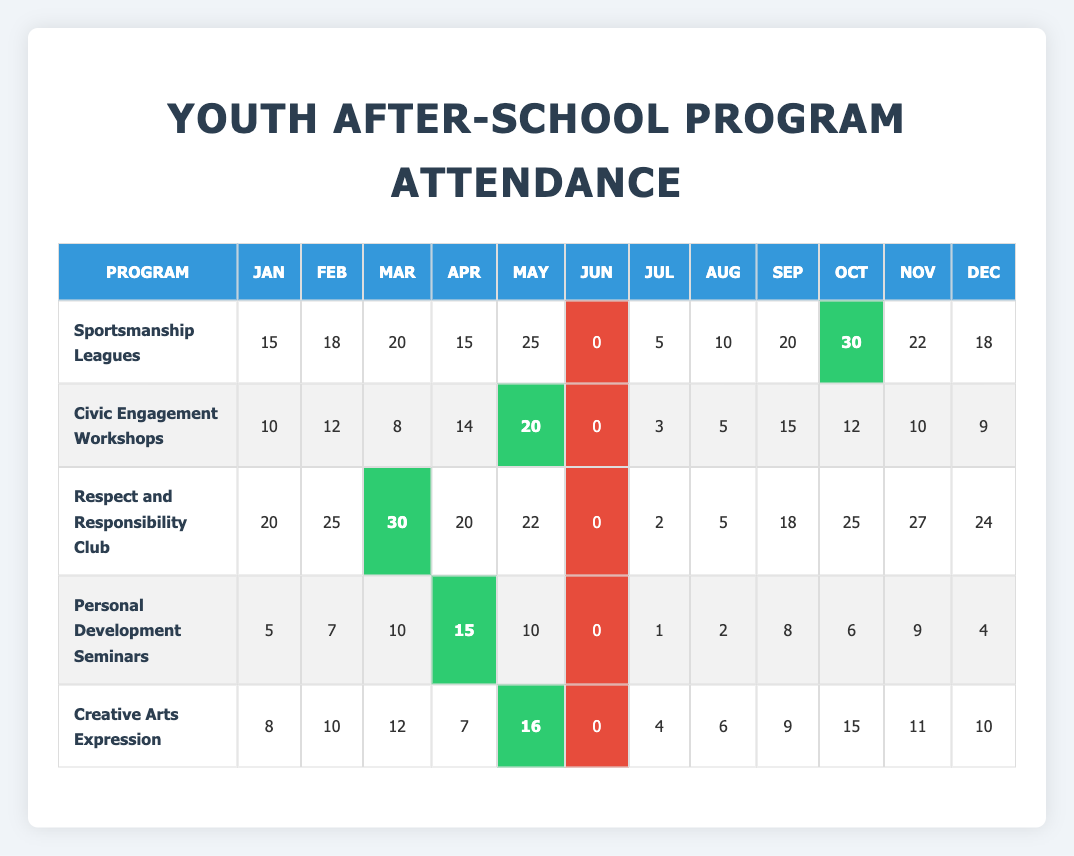What was the attendance in August for the "Sportsmanship Leagues"? The table shows that the "Sportsmanship Leagues" had 10 participants in August.
Answer: 10 Which program had the highest attendance in March? In March, "Respect and Responsibility Club" had 30 participants, which is more than any other program.
Answer: Respect and Responsibility Club What is the total attendance for "Creative Arts Expression" from January to December? Adding together the monthly attendance: 8 + 10 + 12 + 7 + 16 + 0 + 4 + 6 + 9 + 15 + 11 + 10 gives a total of 88 participants.
Answer: 88 Was there a month in which "Personal Development Seminars" had zero attendees? Yes, the data shows that "Personal Development Seminars" had zero attendees in June.
Answer: Yes What is the average attendance for the "Civic Engagement Workshops"? Adding the monthly attendance (10 + 12 + 8 + 14 + 20 + 0 + 3 + 5 + 15 + 12 + 10 + 9 = 108) gives a total of 108; dividing by 12 months gives an average of 9.
Answer: 9 What was the month with the lowest attendance in "Respect and Responsibility Club"? The lowest attendance was in June, with zero participants.
Answer: June Which program had a peak attendance of 30 in which month? The "Sportsmanship Leagues" peaked at 30 participants in October.
Answer: October What can you say about the trend of attendance for "Civic Engagement Workshops" over the year? Looking at the monthly data, attendance fluctuates, with a peak in May (20) followed by declines in June (0) and some growth again towards the end of the year.
Answer: Fluctuating trend Which program showed a consistent increase in attendance month-over-month during the second half of the year? The "Respect and Responsibility Club" showed a consistent increase in attendance month-over-month from July to October.
Answer: Respect and Responsibility Club How does the attendance of "Personal Development Seminars" in September compare to January? In September, attendance was 8, while in January it was 5, showing an increase of 3.
Answer: Increased by 3 